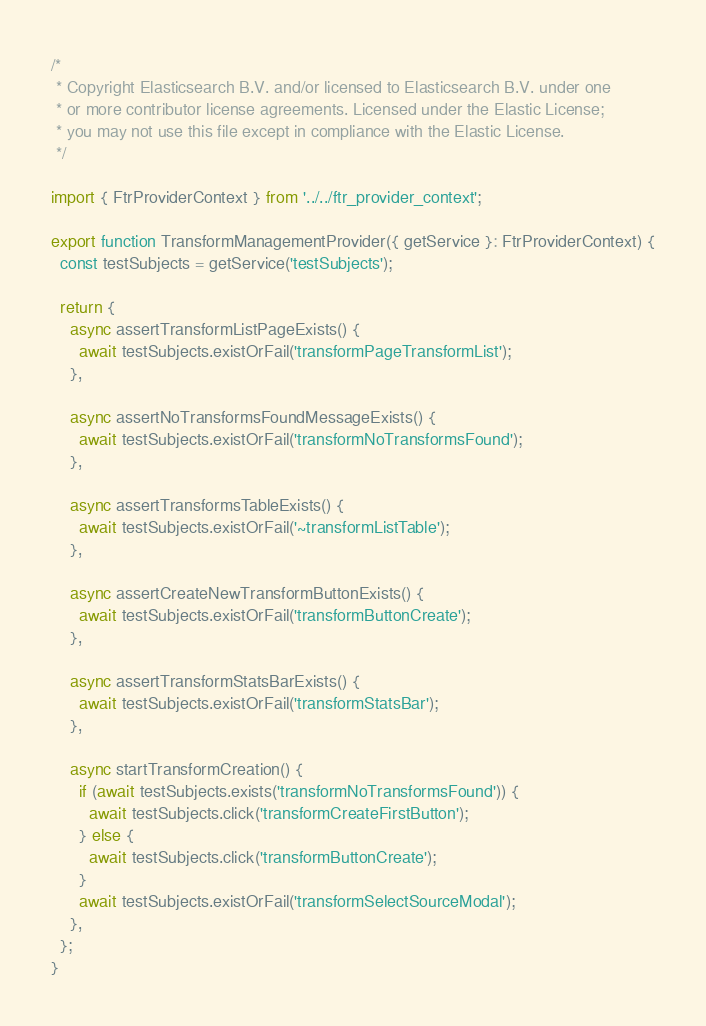<code> <loc_0><loc_0><loc_500><loc_500><_TypeScript_>/*
 * Copyright Elasticsearch B.V. and/or licensed to Elasticsearch B.V. under one
 * or more contributor license agreements. Licensed under the Elastic License;
 * you may not use this file except in compliance with the Elastic License.
 */

import { FtrProviderContext } from '../../ftr_provider_context';

export function TransformManagementProvider({ getService }: FtrProviderContext) {
  const testSubjects = getService('testSubjects');

  return {
    async assertTransformListPageExists() {
      await testSubjects.existOrFail('transformPageTransformList');
    },

    async assertNoTransformsFoundMessageExists() {
      await testSubjects.existOrFail('transformNoTransformsFound');
    },

    async assertTransformsTableExists() {
      await testSubjects.existOrFail('~transformListTable');
    },

    async assertCreateNewTransformButtonExists() {
      await testSubjects.existOrFail('transformButtonCreate');
    },

    async assertTransformStatsBarExists() {
      await testSubjects.existOrFail('transformStatsBar');
    },

    async startTransformCreation() {
      if (await testSubjects.exists('transformNoTransformsFound')) {
        await testSubjects.click('transformCreateFirstButton');
      } else {
        await testSubjects.click('transformButtonCreate');
      }
      await testSubjects.existOrFail('transformSelectSourceModal');
    },
  };
}
</code> 